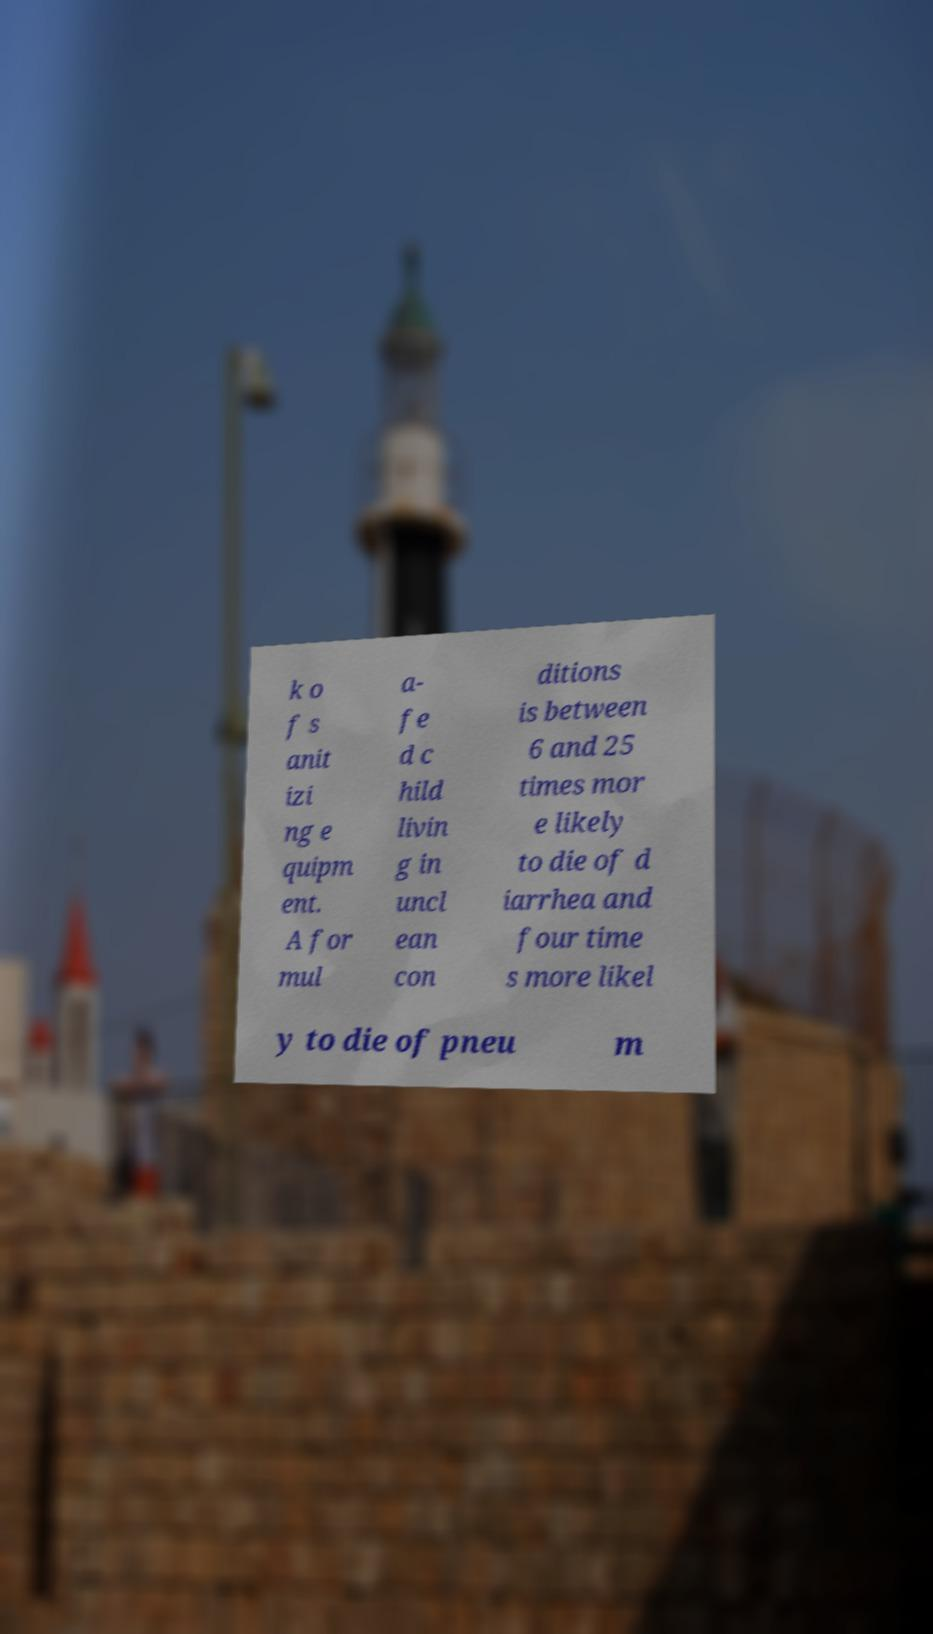There's text embedded in this image that I need extracted. Can you transcribe it verbatim? k o f s anit izi ng e quipm ent. A for mul a- fe d c hild livin g in uncl ean con ditions is between 6 and 25 times mor e likely to die of d iarrhea and four time s more likel y to die of pneu m 